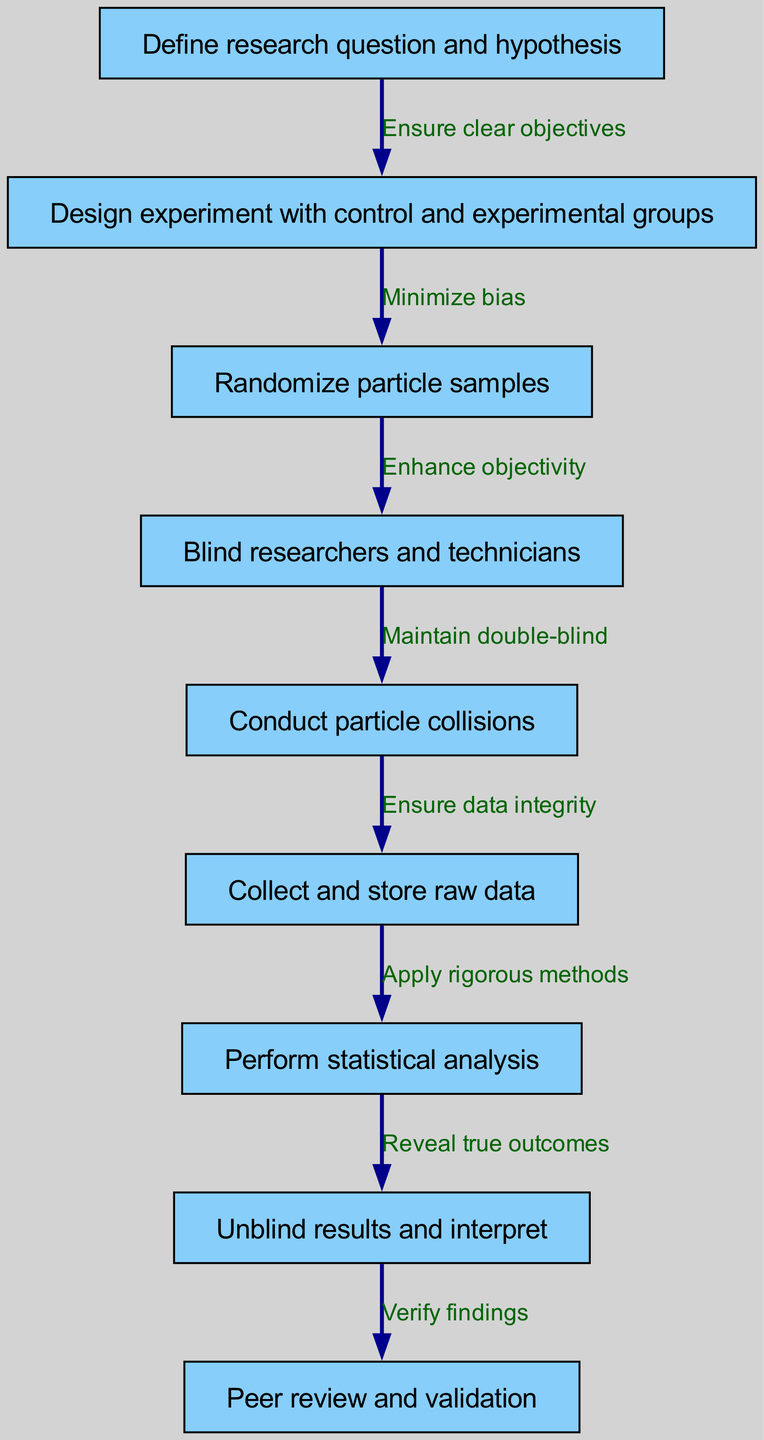What is the first step in the clinical pathway? The first node in the diagram represents the initial action to take, which is "Define research question and hypothesis." This is indicated by the placement and order of the nodes.
Answer: Define research question and hypothesis How many nodes are present in the diagram? By counting the distinct elements labeled as nodes in the provided data, we find there are a total of nine nodes.
Answer: Nine Which two nodes are connected by the phrase "Minimize bias"? The edge labeled "Minimize bias" connects "Design experiment with control and experimental groups" (node 2) to "Randomize particle samples" (node 3). This relationship is indicated by the directed edge connecting those specific nodes.
Answer: Design experiment with control and experimental groups and Randomize particle samples What step follows "Collect and store raw data"? The node that directly follows "Collect and store raw data" is "Perform statistical analysis." This flow demonstrates the sequence of actions as outlined in the clinical pathway.
Answer: Perform statistical analysis What is the last step before the peer review process? Before reaching the "Peer review and validation" step, the prior action is to "Unblind results and interpret." This is the last node connected to "Peer review and validation" in the pathway.
Answer: Unblind results and interpret How does the diagram ensure double-blind conditions? The double-blind condition is maintained through the connection in the pathway labeled "Maintain double-blind," which links the nodes "Blind researchers and technicians" and "Conduct particle collisions." This illustrates the structural element to uphold the double-blind approach in the experiment.
Answer: Maintain double-blind What action is taken after performing statistical analysis? Following the "Perform statistical analysis" step, the subsequent action is to "Unblind results and interpret," which indicates how the analysis leads to result interpretation.
Answer: Unblind results and interpret What does the edge from "Randomize particle samples" to "Blind researchers and technicians" represent? This edge signifies the step that enhances objectivity in the experiment design, ensuring that the randomization of samples contributes to the blinding process as indicated by the text on the edge.
Answer: Enhance objectivity 